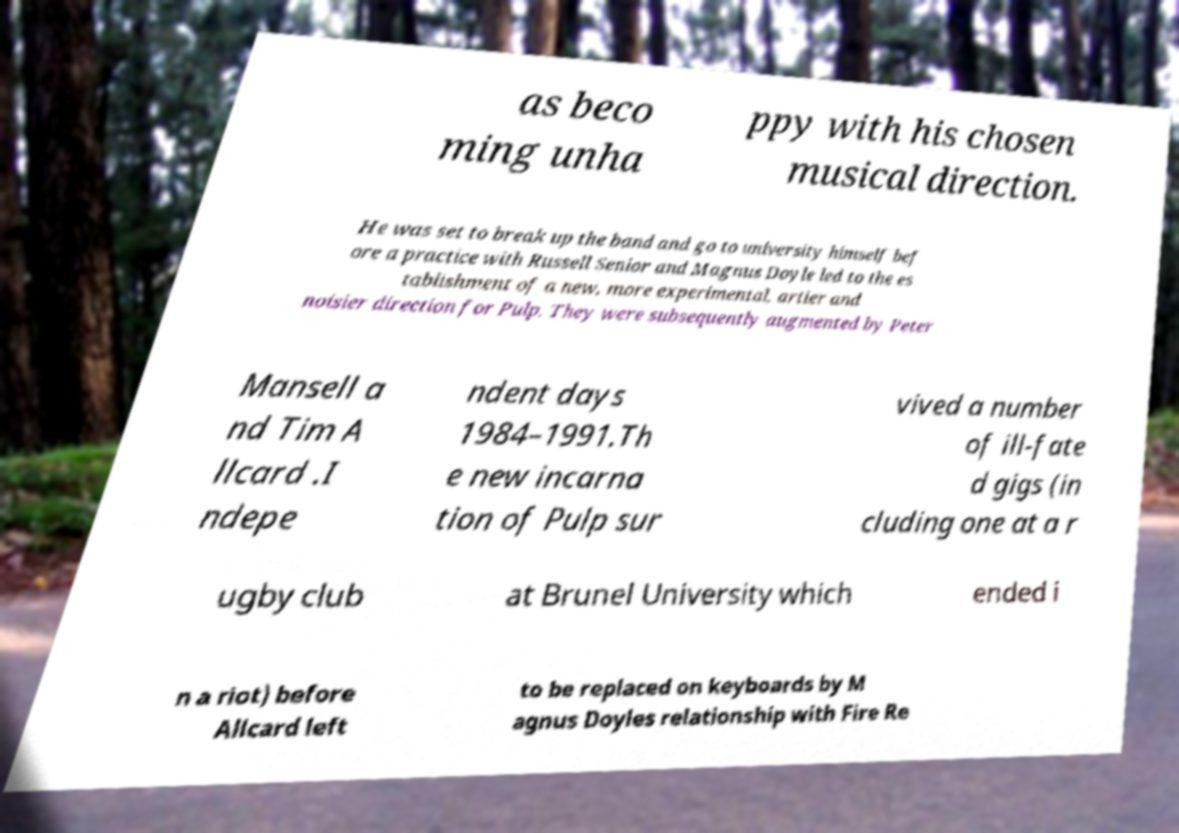For documentation purposes, I need the text within this image transcribed. Could you provide that? as beco ming unha ppy with his chosen musical direction. He was set to break up the band and go to university himself bef ore a practice with Russell Senior and Magnus Doyle led to the es tablishment of a new, more experimental, artier and noisier direction for Pulp. They were subsequently augmented by Peter Mansell a nd Tim A llcard .I ndepe ndent days 1984–1991.Th e new incarna tion of Pulp sur vived a number of ill-fate d gigs (in cluding one at a r ugby club at Brunel University which ended i n a riot) before Allcard left to be replaced on keyboards by M agnus Doyles relationship with Fire Re 